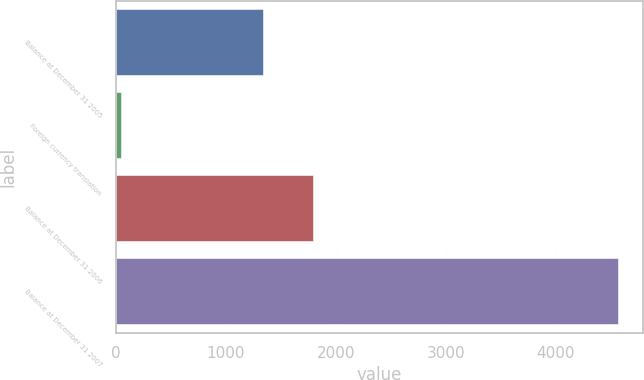Convert chart to OTSL. <chart><loc_0><loc_0><loc_500><loc_500><bar_chart><fcel>Balance at December 31 2005<fcel>Foreign currency translation<fcel>Balance at December 31 2006<fcel>Balance at December 31 2007<nl><fcel>1337<fcel>47<fcel>1789<fcel>4567<nl></chart> 